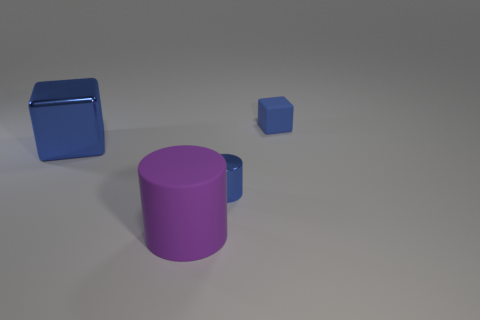What number of things are the same color as the small rubber cube?
Keep it short and to the point. 2. What number of things are either cubes on the right side of the large blue shiny block or blue blocks that are on the right side of the large cube?
Your answer should be compact. 1. There is a blue object that is the same size as the purple thing; what material is it?
Make the answer very short. Metal. How many other things are there of the same material as the tiny blue cylinder?
Your answer should be very brief. 1. Are there an equal number of large blue objects that are to the right of the big blue thing and big cylinders behind the blue matte thing?
Make the answer very short. Yes. How many yellow things are either big metal objects or cylinders?
Your answer should be compact. 0. Does the shiny cylinder have the same color as the block that is behind the big blue thing?
Your response must be concise. Yes. How many other objects are there of the same color as the metallic cylinder?
Make the answer very short. 2. Is the number of big cylinders less than the number of green matte cylinders?
Provide a short and direct response. No. What number of shiny things are behind the blue object that is behind the metallic object to the left of the big cylinder?
Make the answer very short. 0. 